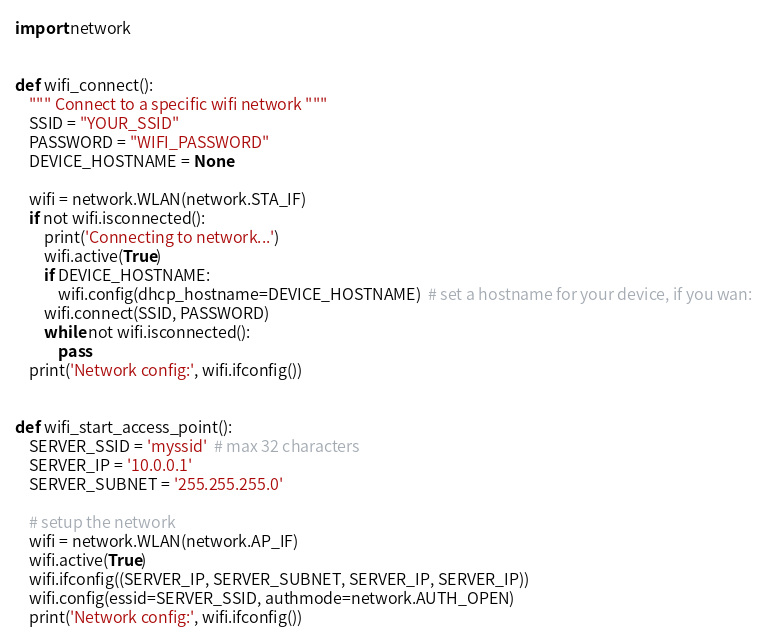<code> <loc_0><loc_0><loc_500><loc_500><_Python_>import network


def wifi_connect():
    """ Connect to a specific wifi network """
    SSID = "YOUR_SSID"
    PASSWORD = "WIFI_PASSWORD"
    DEVICE_HOSTNAME = None

    wifi = network.WLAN(network.STA_IF)
    if not wifi.isconnected():
        print('Connecting to network...')
        wifi.active(True)
        if DEVICE_HOSTNAME:
            wifi.config(dhcp_hostname=DEVICE_HOSTNAME)  # set a hostname for your device, if you wan:
        wifi.connect(SSID, PASSWORD)
        while not wifi.isconnected():
            pass
    print('Network config:', wifi.ifconfig())


def wifi_start_access_point():
    SERVER_SSID = 'myssid'  # max 32 characters
    SERVER_IP = '10.0.0.1'
    SERVER_SUBNET = '255.255.255.0'

    # setup the network
    wifi = network.WLAN(network.AP_IF)
    wifi.active(True)
    wifi.ifconfig((SERVER_IP, SERVER_SUBNET, SERVER_IP, SERVER_IP))
    wifi.config(essid=SERVER_SSID, authmode=network.AUTH_OPEN)
    print('Network config:', wifi.ifconfig())
</code> 